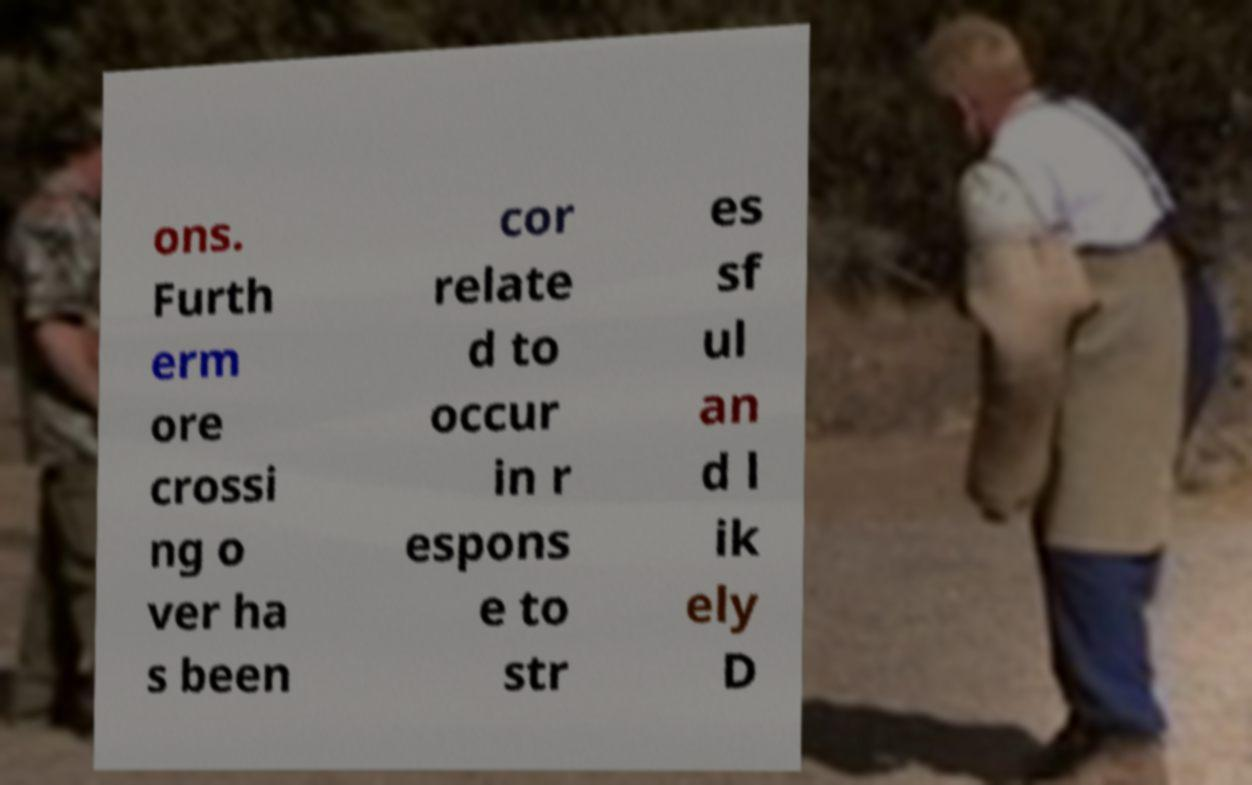Please read and relay the text visible in this image. What does it say? ons. Furth erm ore crossi ng o ver ha s been cor relate d to occur in r espons e to str es sf ul an d l ik ely D 